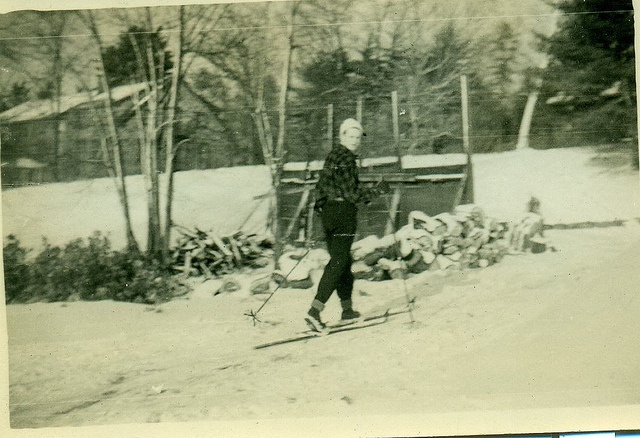Describe the objects in this image and their specific colors. I can see people in beige, black, and darkgreen tones and skis in beige, tan, gray, and olive tones in this image. 